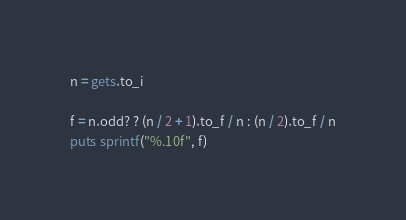<code> <loc_0><loc_0><loc_500><loc_500><_Ruby_>n = gets.to_i

f = n.odd? ? (n / 2 + 1).to_f / n : (n / 2).to_f / n
puts sprintf("%.10f", f)</code> 